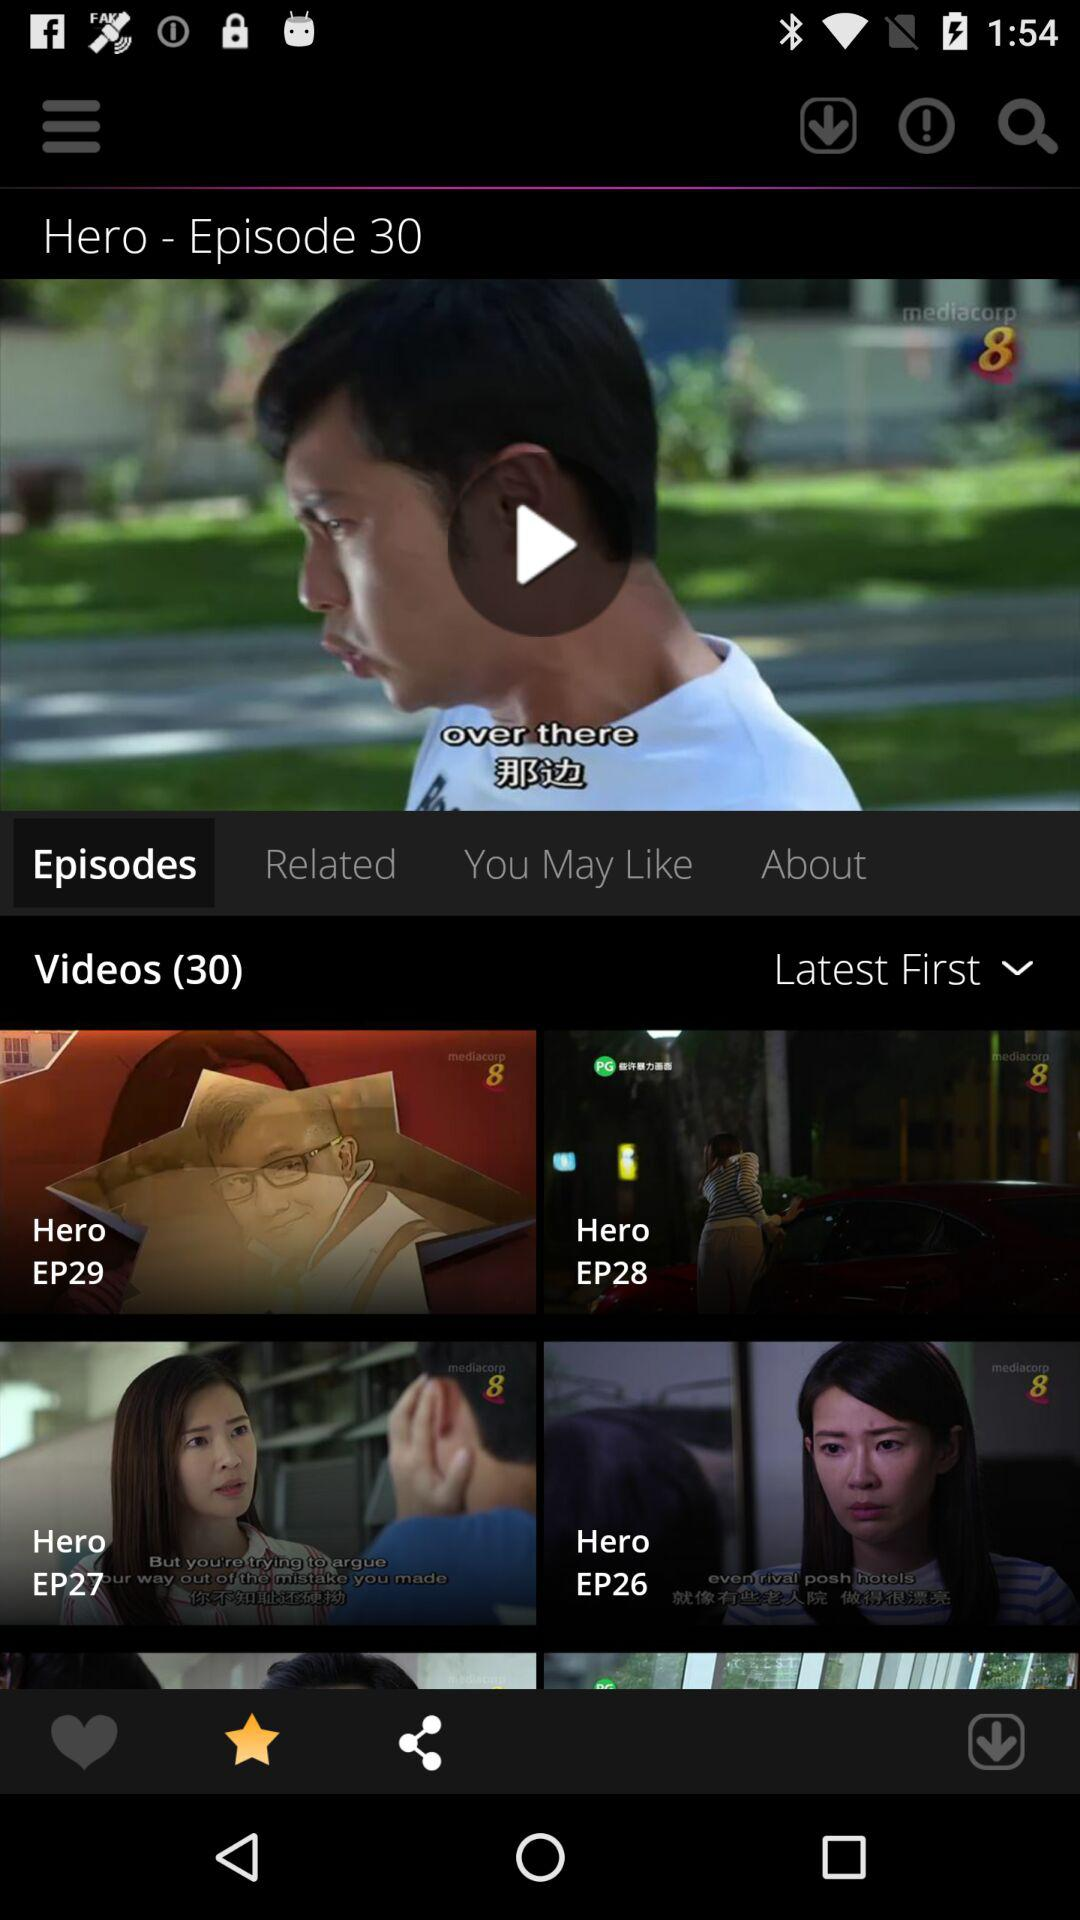Which tab is currently selected? The currently selected tab is "Episodes". 